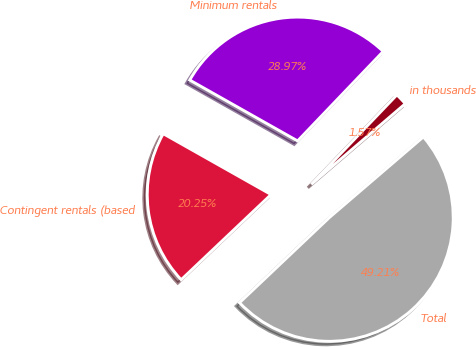Convert chart to OTSL. <chart><loc_0><loc_0><loc_500><loc_500><pie_chart><fcel>in thousands<fcel>Minimum rentals<fcel>Contingent rentals (based<fcel>Total<nl><fcel>1.57%<fcel>28.97%<fcel>20.25%<fcel>49.21%<nl></chart> 